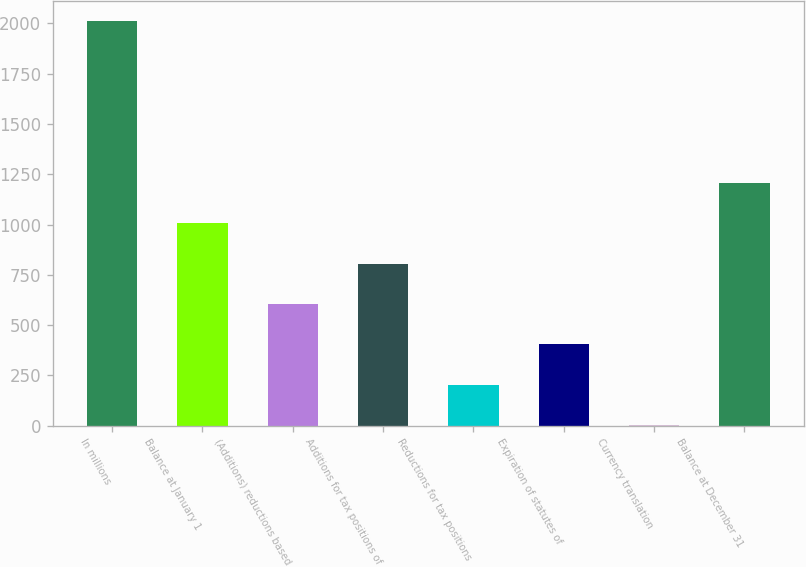<chart> <loc_0><loc_0><loc_500><loc_500><bar_chart><fcel>In millions<fcel>Balance at January 1<fcel>(Additions) reductions based<fcel>Additions for tax positions of<fcel>Reductions for tax positions<fcel>Expiration of statutes of<fcel>Currency translation<fcel>Balance at December 31<nl><fcel>2012<fcel>1007<fcel>605<fcel>806<fcel>203<fcel>404<fcel>2<fcel>1208<nl></chart> 